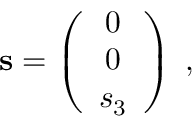<formula> <loc_0><loc_0><loc_500><loc_500>{ s } = \left ( \begin{array} { c } { 0 } \\ { 0 } \\ { { s _ { 3 } } } \end{array} \right ) \, ,</formula> 